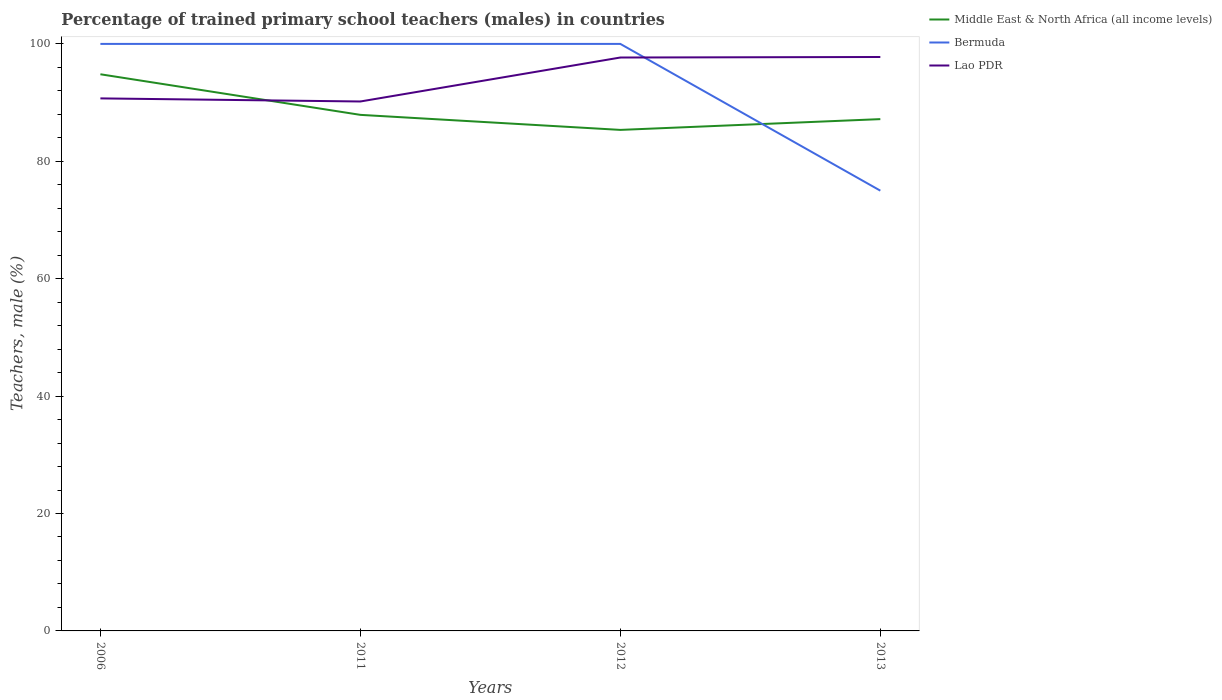Does the line corresponding to Middle East & North Africa (all income levels) intersect with the line corresponding to Lao PDR?
Your response must be concise. Yes. Across all years, what is the maximum percentage of trained primary school teachers (males) in Lao PDR?
Your response must be concise. 90.19. In which year was the percentage of trained primary school teachers (males) in Bermuda maximum?
Your answer should be compact. 2013. What is the total percentage of trained primary school teachers (males) in Lao PDR in the graph?
Offer a very short reply. -7.58. What is the difference between the highest and the lowest percentage of trained primary school teachers (males) in Middle East & North Africa (all income levels)?
Keep it short and to the point. 1. How many lines are there?
Ensure brevity in your answer.  3. How many years are there in the graph?
Provide a succinct answer. 4. Are the values on the major ticks of Y-axis written in scientific E-notation?
Your response must be concise. No. Does the graph contain any zero values?
Your response must be concise. No. Does the graph contain grids?
Offer a terse response. No. Where does the legend appear in the graph?
Offer a terse response. Top right. What is the title of the graph?
Offer a very short reply. Percentage of trained primary school teachers (males) in countries. What is the label or title of the Y-axis?
Ensure brevity in your answer.  Teachers, male (%). What is the Teachers, male (%) of Middle East & North Africa (all income levels) in 2006?
Offer a terse response. 94.83. What is the Teachers, male (%) in Bermuda in 2006?
Your response must be concise. 100. What is the Teachers, male (%) of Lao PDR in 2006?
Provide a short and direct response. 90.72. What is the Teachers, male (%) of Middle East & North Africa (all income levels) in 2011?
Your answer should be compact. 87.91. What is the Teachers, male (%) of Lao PDR in 2011?
Your response must be concise. 90.19. What is the Teachers, male (%) in Middle East & North Africa (all income levels) in 2012?
Make the answer very short. 85.35. What is the Teachers, male (%) in Bermuda in 2012?
Offer a very short reply. 100. What is the Teachers, male (%) in Lao PDR in 2012?
Make the answer very short. 97.68. What is the Teachers, male (%) in Middle East & North Africa (all income levels) in 2013?
Give a very brief answer. 87.19. What is the Teachers, male (%) of Lao PDR in 2013?
Offer a very short reply. 97.77. Across all years, what is the maximum Teachers, male (%) in Middle East & North Africa (all income levels)?
Your response must be concise. 94.83. Across all years, what is the maximum Teachers, male (%) in Bermuda?
Provide a succinct answer. 100. Across all years, what is the maximum Teachers, male (%) of Lao PDR?
Keep it short and to the point. 97.77. Across all years, what is the minimum Teachers, male (%) of Middle East & North Africa (all income levels)?
Make the answer very short. 85.35. Across all years, what is the minimum Teachers, male (%) of Bermuda?
Give a very brief answer. 75. Across all years, what is the minimum Teachers, male (%) in Lao PDR?
Your answer should be very brief. 90.19. What is the total Teachers, male (%) of Middle East & North Africa (all income levels) in the graph?
Provide a short and direct response. 355.28. What is the total Teachers, male (%) in Bermuda in the graph?
Your answer should be very brief. 375. What is the total Teachers, male (%) in Lao PDR in the graph?
Ensure brevity in your answer.  376.36. What is the difference between the Teachers, male (%) in Middle East & North Africa (all income levels) in 2006 and that in 2011?
Provide a succinct answer. 6.92. What is the difference between the Teachers, male (%) of Lao PDR in 2006 and that in 2011?
Provide a succinct answer. 0.53. What is the difference between the Teachers, male (%) of Middle East & North Africa (all income levels) in 2006 and that in 2012?
Make the answer very short. 9.48. What is the difference between the Teachers, male (%) of Bermuda in 2006 and that in 2012?
Provide a short and direct response. 0. What is the difference between the Teachers, male (%) of Lao PDR in 2006 and that in 2012?
Keep it short and to the point. -6.96. What is the difference between the Teachers, male (%) of Middle East & North Africa (all income levels) in 2006 and that in 2013?
Keep it short and to the point. 7.64. What is the difference between the Teachers, male (%) in Lao PDR in 2006 and that in 2013?
Offer a very short reply. -7.05. What is the difference between the Teachers, male (%) in Middle East & North Africa (all income levels) in 2011 and that in 2012?
Provide a short and direct response. 2.56. What is the difference between the Teachers, male (%) in Lao PDR in 2011 and that in 2012?
Your answer should be compact. -7.49. What is the difference between the Teachers, male (%) of Middle East & North Africa (all income levels) in 2011 and that in 2013?
Offer a terse response. 0.73. What is the difference between the Teachers, male (%) in Lao PDR in 2011 and that in 2013?
Provide a short and direct response. -7.58. What is the difference between the Teachers, male (%) of Middle East & North Africa (all income levels) in 2012 and that in 2013?
Your response must be concise. -1.84. What is the difference between the Teachers, male (%) of Bermuda in 2012 and that in 2013?
Give a very brief answer. 25. What is the difference between the Teachers, male (%) in Lao PDR in 2012 and that in 2013?
Provide a succinct answer. -0.09. What is the difference between the Teachers, male (%) of Middle East & North Africa (all income levels) in 2006 and the Teachers, male (%) of Bermuda in 2011?
Your response must be concise. -5.17. What is the difference between the Teachers, male (%) in Middle East & North Africa (all income levels) in 2006 and the Teachers, male (%) in Lao PDR in 2011?
Give a very brief answer. 4.64. What is the difference between the Teachers, male (%) of Bermuda in 2006 and the Teachers, male (%) of Lao PDR in 2011?
Make the answer very short. 9.81. What is the difference between the Teachers, male (%) in Middle East & North Africa (all income levels) in 2006 and the Teachers, male (%) in Bermuda in 2012?
Offer a terse response. -5.17. What is the difference between the Teachers, male (%) of Middle East & North Africa (all income levels) in 2006 and the Teachers, male (%) of Lao PDR in 2012?
Keep it short and to the point. -2.85. What is the difference between the Teachers, male (%) in Bermuda in 2006 and the Teachers, male (%) in Lao PDR in 2012?
Provide a succinct answer. 2.32. What is the difference between the Teachers, male (%) of Middle East & North Africa (all income levels) in 2006 and the Teachers, male (%) of Bermuda in 2013?
Provide a succinct answer. 19.83. What is the difference between the Teachers, male (%) in Middle East & North Africa (all income levels) in 2006 and the Teachers, male (%) in Lao PDR in 2013?
Ensure brevity in your answer.  -2.94. What is the difference between the Teachers, male (%) in Bermuda in 2006 and the Teachers, male (%) in Lao PDR in 2013?
Provide a succinct answer. 2.23. What is the difference between the Teachers, male (%) in Middle East & North Africa (all income levels) in 2011 and the Teachers, male (%) in Bermuda in 2012?
Keep it short and to the point. -12.09. What is the difference between the Teachers, male (%) in Middle East & North Africa (all income levels) in 2011 and the Teachers, male (%) in Lao PDR in 2012?
Give a very brief answer. -9.77. What is the difference between the Teachers, male (%) of Bermuda in 2011 and the Teachers, male (%) of Lao PDR in 2012?
Your response must be concise. 2.32. What is the difference between the Teachers, male (%) in Middle East & North Africa (all income levels) in 2011 and the Teachers, male (%) in Bermuda in 2013?
Ensure brevity in your answer.  12.91. What is the difference between the Teachers, male (%) in Middle East & North Africa (all income levels) in 2011 and the Teachers, male (%) in Lao PDR in 2013?
Give a very brief answer. -9.86. What is the difference between the Teachers, male (%) in Bermuda in 2011 and the Teachers, male (%) in Lao PDR in 2013?
Offer a very short reply. 2.23. What is the difference between the Teachers, male (%) in Middle East & North Africa (all income levels) in 2012 and the Teachers, male (%) in Bermuda in 2013?
Your answer should be very brief. 10.35. What is the difference between the Teachers, male (%) in Middle East & North Africa (all income levels) in 2012 and the Teachers, male (%) in Lao PDR in 2013?
Ensure brevity in your answer.  -12.42. What is the difference between the Teachers, male (%) of Bermuda in 2012 and the Teachers, male (%) of Lao PDR in 2013?
Your answer should be very brief. 2.23. What is the average Teachers, male (%) in Middle East & North Africa (all income levels) per year?
Your answer should be compact. 88.82. What is the average Teachers, male (%) of Bermuda per year?
Your answer should be compact. 93.75. What is the average Teachers, male (%) in Lao PDR per year?
Your answer should be compact. 94.09. In the year 2006, what is the difference between the Teachers, male (%) of Middle East & North Africa (all income levels) and Teachers, male (%) of Bermuda?
Provide a succinct answer. -5.17. In the year 2006, what is the difference between the Teachers, male (%) in Middle East & North Africa (all income levels) and Teachers, male (%) in Lao PDR?
Provide a succinct answer. 4.11. In the year 2006, what is the difference between the Teachers, male (%) of Bermuda and Teachers, male (%) of Lao PDR?
Ensure brevity in your answer.  9.28. In the year 2011, what is the difference between the Teachers, male (%) in Middle East & North Africa (all income levels) and Teachers, male (%) in Bermuda?
Make the answer very short. -12.09. In the year 2011, what is the difference between the Teachers, male (%) of Middle East & North Africa (all income levels) and Teachers, male (%) of Lao PDR?
Provide a succinct answer. -2.28. In the year 2011, what is the difference between the Teachers, male (%) of Bermuda and Teachers, male (%) of Lao PDR?
Provide a succinct answer. 9.81. In the year 2012, what is the difference between the Teachers, male (%) in Middle East & North Africa (all income levels) and Teachers, male (%) in Bermuda?
Ensure brevity in your answer.  -14.65. In the year 2012, what is the difference between the Teachers, male (%) in Middle East & North Africa (all income levels) and Teachers, male (%) in Lao PDR?
Offer a very short reply. -12.33. In the year 2012, what is the difference between the Teachers, male (%) of Bermuda and Teachers, male (%) of Lao PDR?
Offer a very short reply. 2.32. In the year 2013, what is the difference between the Teachers, male (%) in Middle East & North Africa (all income levels) and Teachers, male (%) in Bermuda?
Offer a terse response. 12.19. In the year 2013, what is the difference between the Teachers, male (%) of Middle East & North Africa (all income levels) and Teachers, male (%) of Lao PDR?
Offer a terse response. -10.58. In the year 2013, what is the difference between the Teachers, male (%) in Bermuda and Teachers, male (%) in Lao PDR?
Offer a terse response. -22.77. What is the ratio of the Teachers, male (%) in Middle East & North Africa (all income levels) in 2006 to that in 2011?
Provide a short and direct response. 1.08. What is the ratio of the Teachers, male (%) of Lao PDR in 2006 to that in 2011?
Your answer should be compact. 1.01. What is the ratio of the Teachers, male (%) of Middle East & North Africa (all income levels) in 2006 to that in 2012?
Your answer should be very brief. 1.11. What is the ratio of the Teachers, male (%) of Bermuda in 2006 to that in 2012?
Your answer should be very brief. 1. What is the ratio of the Teachers, male (%) in Lao PDR in 2006 to that in 2012?
Offer a terse response. 0.93. What is the ratio of the Teachers, male (%) in Middle East & North Africa (all income levels) in 2006 to that in 2013?
Your answer should be very brief. 1.09. What is the ratio of the Teachers, male (%) of Lao PDR in 2006 to that in 2013?
Your answer should be very brief. 0.93. What is the ratio of the Teachers, male (%) of Middle East & North Africa (all income levels) in 2011 to that in 2012?
Make the answer very short. 1.03. What is the ratio of the Teachers, male (%) of Lao PDR in 2011 to that in 2012?
Offer a terse response. 0.92. What is the ratio of the Teachers, male (%) of Middle East & North Africa (all income levels) in 2011 to that in 2013?
Keep it short and to the point. 1.01. What is the ratio of the Teachers, male (%) of Bermuda in 2011 to that in 2013?
Your answer should be very brief. 1.33. What is the ratio of the Teachers, male (%) of Lao PDR in 2011 to that in 2013?
Your answer should be compact. 0.92. What is the ratio of the Teachers, male (%) in Middle East & North Africa (all income levels) in 2012 to that in 2013?
Provide a short and direct response. 0.98. What is the ratio of the Teachers, male (%) of Lao PDR in 2012 to that in 2013?
Your response must be concise. 1. What is the difference between the highest and the second highest Teachers, male (%) in Middle East & North Africa (all income levels)?
Offer a very short reply. 6.92. What is the difference between the highest and the second highest Teachers, male (%) of Bermuda?
Offer a terse response. 0. What is the difference between the highest and the second highest Teachers, male (%) in Lao PDR?
Give a very brief answer. 0.09. What is the difference between the highest and the lowest Teachers, male (%) in Middle East & North Africa (all income levels)?
Your answer should be compact. 9.48. What is the difference between the highest and the lowest Teachers, male (%) in Bermuda?
Offer a very short reply. 25. What is the difference between the highest and the lowest Teachers, male (%) of Lao PDR?
Keep it short and to the point. 7.58. 